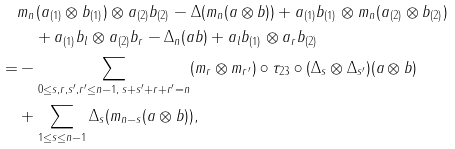<formula> <loc_0><loc_0><loc_500><loc_500>& m _ { n } ( a _ { ( 1 ) } \otimes b _ { ( 1 ) } ) \otimes a _ { ( 2 ) } b _ { ( 2 ) } - \Delta ( m _ { n } ( a \otimes b ) ) + a _ { ( 1 ) } b _ { ( 1 ) } \otimes m _ { n } ( a _ { ( 2 ) } \otimes b _ { ( 2 ) } ) \\ & \quad + a _ { ( 1 ) } b _ { l } \otimes a _ { ( 2 ) } b _ { r } - \Delta _ { n } ( a b ) + a _ { l } b _ { ( 1 ) } \otimes a _ { r } b _ { ( 2 ) } \\ = & - \sum _ { 0 \leq s , r , s ^ { \prime } , r ^ { \prime } \leq n - 1 , \, s + s ^ { \prime } + r + r ^ { \prime } = n } ( m _ { r } \otimes m _ { r ^ { \prime } } ) \circ \tau _ { 2 3 } \circ ( \Delta _ { s } \otimes \Delta _ { s ^ { \prime } } ) ( a \otimes b ) \\ & + \sum _ { 1 \leq s \leq n - 1 } \Delta _ { s } ( m _ { n - s } ( a \otimes b ) ) ,</formula> 